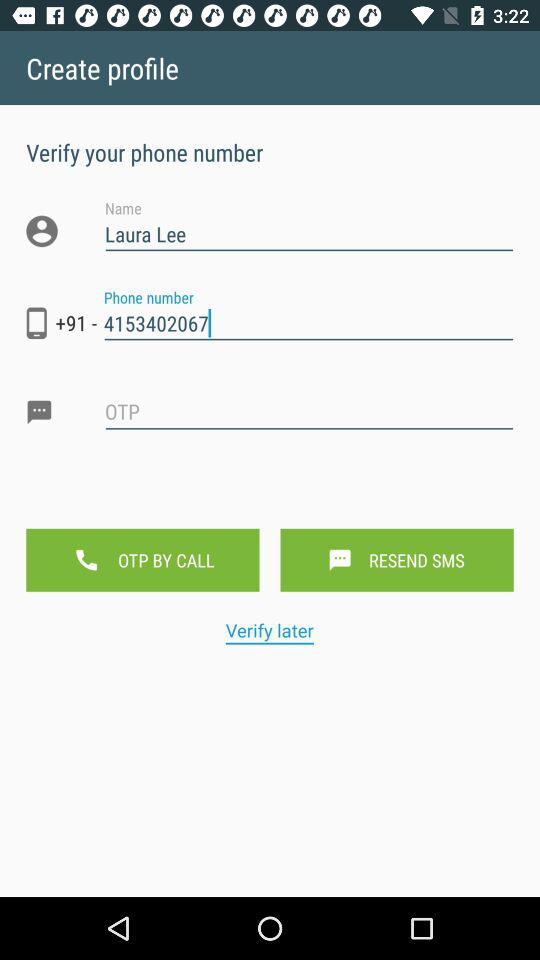What is the contact number? The contact number is +91-4153402067. 